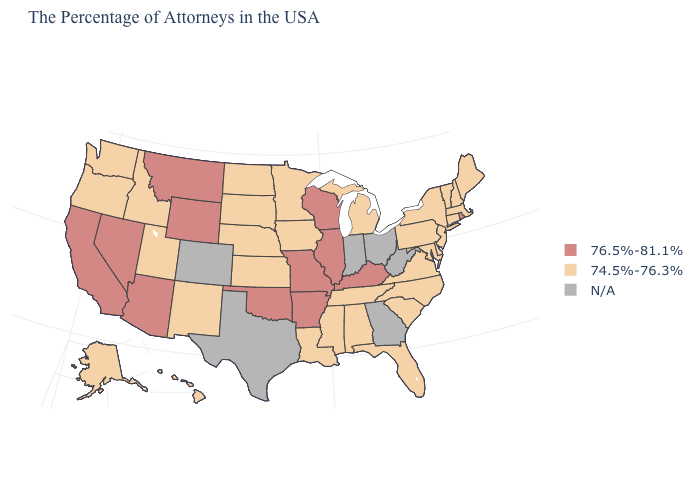Is the legend a continuous bar?
Write a very short answer. No. What is the value of Washington?
Concise answer only. 74.5%-76.3%. What is the value of Utah?
Answer briefly. 74.5%-76.3%. Name the states that have a value in the range N/A?
Keep it brief. West Virginia, Ohio, Georgia, Indiana, Texas, Colorado. Does Illinois have the lowest value in the MidWest?
Give a very brief answer. No. What is the value of Tennessee?
Write a very short answer. 74.5%-76.3%. Name the states that have a value in the range 76.5%-81.1%?
Short answer required. Rhode Island, Kentucky, Wisconsin, Illinois, Missouri, Arkansas, Oklahoma, Wyoming, Montana, Arizona, Nevada, California. Is the legend a continuous bar?
Short answer required. No. Does Connecticut have the lowest value in the Northeast?
Write a very short answer. Yes. Among the states that border Delaware , which have the highest value?
Give a very brief answer. New Jersey, Maryland, Pennsylvania. What is the highest value in the USA?
Be succinct. 76.5%-81.1%. Name the states that have a value in the range 76.5%-81.1%?
Concise answer only. Rhode Island, Kentucky, Wisconsin, Illinois, Missouri, Arkansas, Oklahoma, Wyoming, Montana, Arizona, Nevada, California. What is the value of Alabama?
Short answer required. 74.5%-76.3%. 